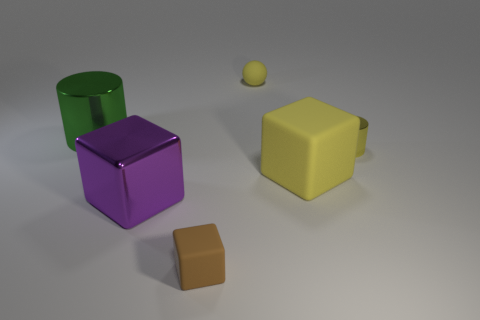What color is the large metallic cylinder?
Provide a succinct answer. Green. What material is the big thing that is the same color as the tiny matte sphere?
Keep it short and to the point. Rubber. Is there a big gray matte object of the same shape as the tiny yellow matte object?
Provide a short and direct response. No. What size is the rubber block to the right of the tiny brown object?
Your answer should be compact. Large. There is a yellow thing that is the same size as the metal block; what material is it?
Make the answer very short. Rubber. Are there more big green metallic cylinders than tiny yellow blocks?
Give a very brief answer. Yes. What is the size of the rubber object that is behind the tiny yellow cylinder in front of the big green metal thing?
Offer a terse response. Small. There is a metal object that is the same size as the purple metal cube; what shape is it?
Your answer should be very brief. Cylinder. There is a rubber thing in front of the large block right of the tiny yellow thing behind the large green shiny cylinder; what shape is it?
Provide a short and direct response. Cube. Does the metal cylinder that is left of the purple object have the same color as the small rubber object that is in front of the tiny yellow metallic thing?
Make the answer very short. No. 